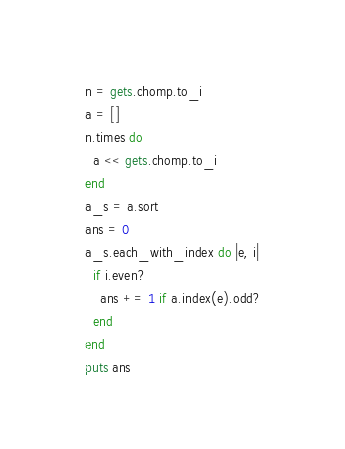<code> <loc_0><loc_0><loc_500><loc_500><_Ruby_>n = gets.chomp.to_i
a = []
n.times do
  a << gets.chomp.to_i
end
a_s = a.sort
ans = 0
a_s.each_with_index do |e, i|
  if i.even?
    ans += 1 if a.index(e).odd?  
  end
end
puts ans
</code> 